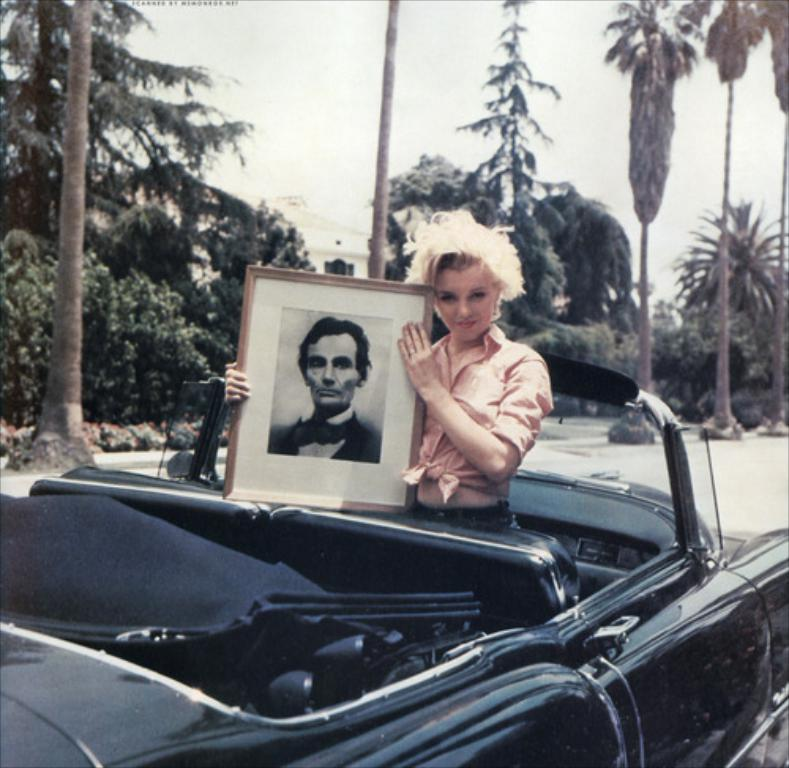Who is present in the image? There is a lady in the image. What is the lady holding in the image? The lady is holding a picture of a man. Where is the lady standing in the image? The lady is standing in a car. What color is the car in the image? The car is black. What can be seen in the background of the image? There are trees visible on the road in the image. What type of feast is being prepared by the squirrel in the image? There is no squirrel present in the image, and therefore no feast being prepared. 